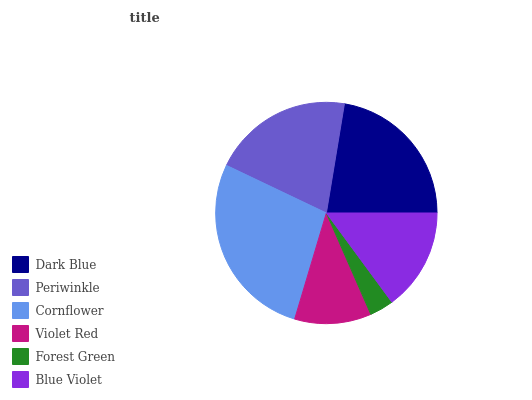Is Forest Green the minimum?
Answer yes or no. Yes. Is Cornflower the maximum?
Answer yes or no. Yes. Is Periwinkle the minimum?
Answer yes or no. No. Is Periwinkle the maximum?
Answer yes or no. No. Is Dark Blue greater than Periwinkle?
Answer yes or no. Yes. Is Periwinkle less than Dark Blue?
Answer yes or no. Yes. Is Periwinkle greater than Dark Blue?
Answer yes or no. No. Is Dark Blue less than Periwinkle?
Answer yes or no. No. Is Periwinkle the high median?
Answer yes or no. Yes. Is Blue Violet the low median?
Answer yes or no. Yes. Is Blue Violet the high median?
Answer yes or no. No. Is Forest Green the low median?
Answer yes or no. No. 